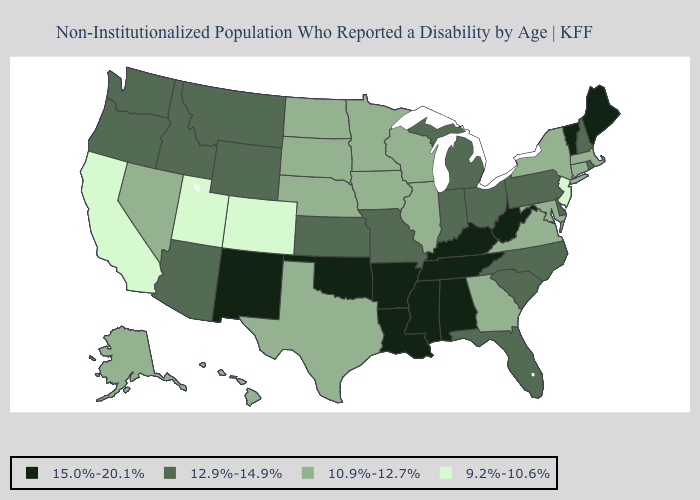What is the value of Minnesota?
Give a very brief answer. 10.9%-12.7%. What is the value of Texas?
Be succinct. 10.9%-12.7%. Name the states that have a value in the range 10.9%-12.7%?
Give a very brief answer. Alaska, Connecticut, Georgia, Hawaii, Illinois, Iowa, Maryland, Massachusetts, Minnesota, Nebraska, Nevada, New York, North Dakota, South Dakota, Texas, Virginia, Wisconsin. Does Michigan have a lower value than West Virginia?
Be succinct. Yes. What is the value of Hawaii?
Keep it brief. 10.9%-12.7%. What is the value of Arkansas?
Quick response, please. 15.0%-20.1%. Name the states that have a value in the range 12.9%-14.9%?
Quick response, please. Arizona, Delaware, Florida, Idaho, Indiana, Kansas, Michigan, Missouri, Montana, New Hampshire, North Carolina, Ohio, Oregon, Pennsylvania, Rhode Island, South Carolina, Washington, Wyoming. Does the first symbol in the legend represent the smallest category?
Write a very short answer. No. Name the states that have a value in the range 12.9%-14.9%?
Keep it brief. Arizona, Delaware, Florida, Idaho, Indiana, Kansas, Michigan, Missouri, Montana, New Hampshire, North Carolina, Ohio, Oregon, Pennsylvania, Rhode Island, South Carolina, Washington, Wyoming. How many symbols are there in the legend?
Short answer required. 4. Does the first symbol in the legend represent the smallest category?
Give a very brief answer. No. What is the value of Tennessee?
Keep it brief. 15.0%-20.1%. Name the states that have a value in the range 15.0%-20.1%?
Keep it brief. Alabama, Arkansas, Kentucky, Louisiana, Maine, Mississippi, New Mexico, Oklahoma, Tennessee, Vermont, West Virginia. Does the map have missing data?
Concise answer only. No. Among the states that border Louisiana , does Texas have the highest value?
Keep it brief. No. 